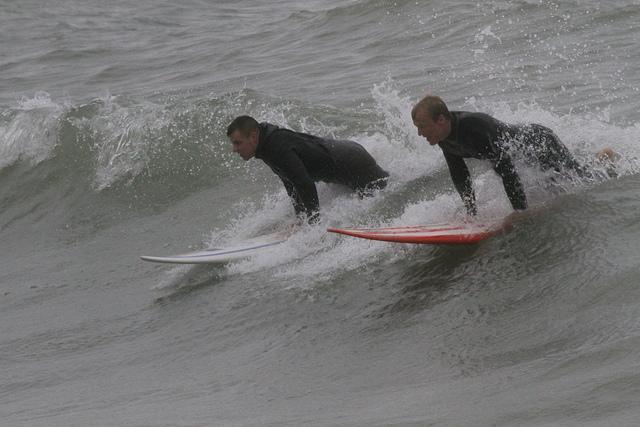What are the men on the boards attempting to do?
Select the accurate answer and provide justification: `Answer: choice
Rationale: srationale.`
Options: Stand, lay, dive, jump. Answer: stand.
Rationale: The men on the boards want to stand up. 